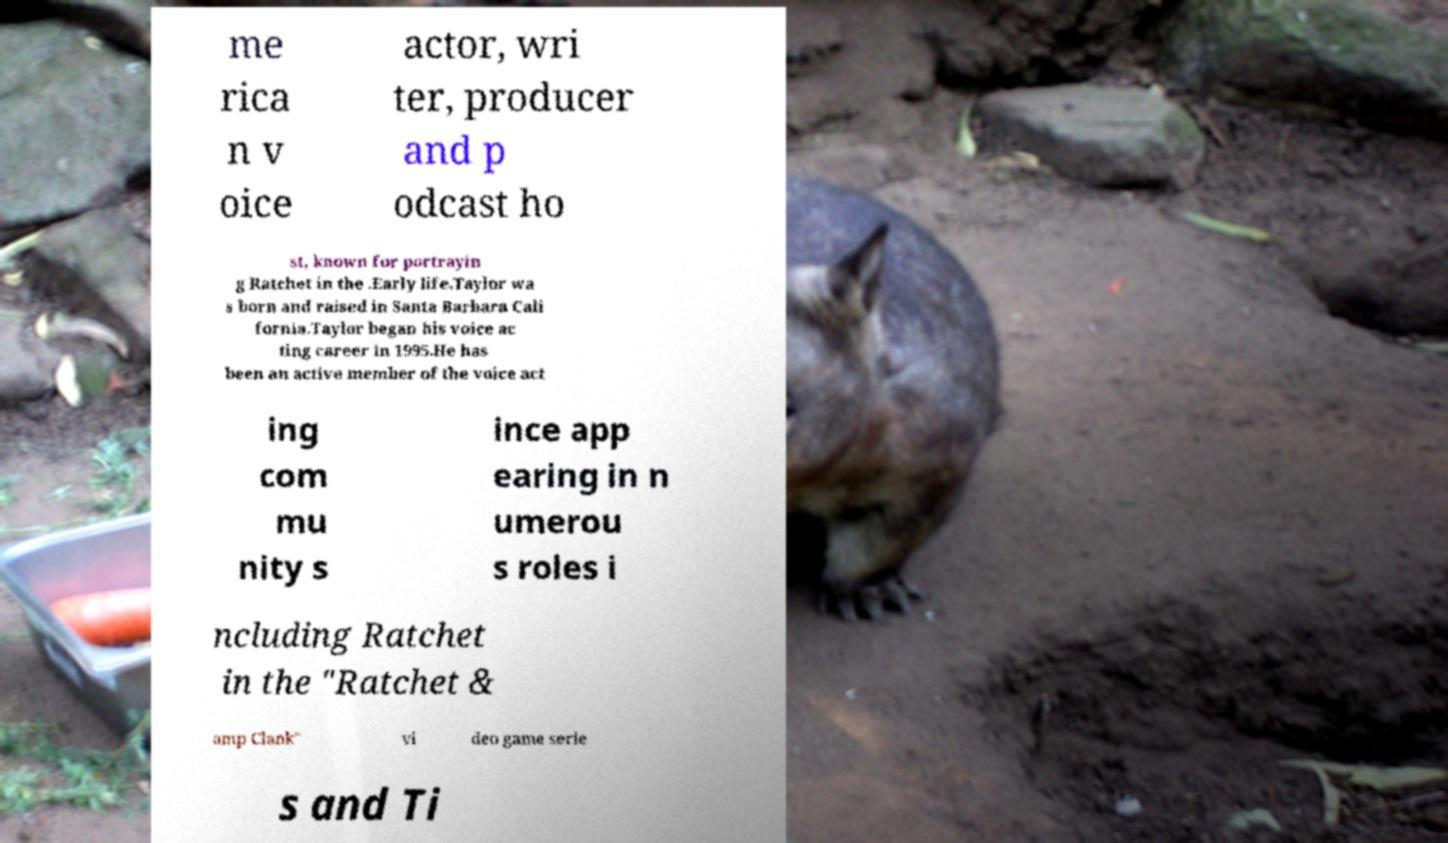Could you extract and type out the text from this image? me rica n v oice actor, wri ter, producer and p odcast ho st, known for portrayin g Ratchet in the .Early life.Taylor wa s born and raised in Santa Barbara Cali fornia.Taylor began his voice ac ting career in 1995.He has been an active member of the voice act ing com mu nity s ince app earing in n umerou s roles i ncluding Ratchet in the "Ratchet & amp Clank" vi deo game serie s and Ti 